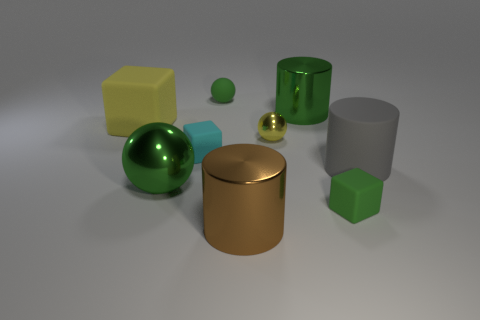Subtract 1 cylinders. How many cylinders are left? 2 Add 1 small blue spheres. How many objects exist? 10 Subtract all cylinders. How many objects are left? 6 Add 7 green metallic cylinders. How many green metallic cylinders are left? 8 Add 9 big green balls. How many big green balls exist? 10 Subtract 0 cyan balls. How many objects are left? 9 Subtract all large purple rubber balls. Subtract all matte cylinders. How many objects are left? 8 